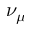<formula> <loc_0><loc_0><loc_500><loc_500>\nu _ { \mu }</formula> 